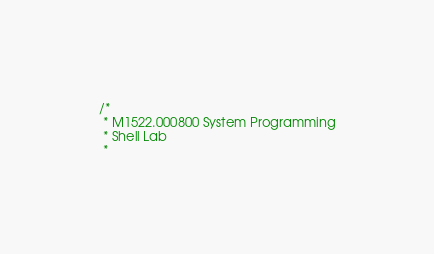<code> <loc_0><loc_0><loc_500><loc_500><_C_>/*
 * M1522.000800 System Programming
 * Shell Lab
 *</code> 